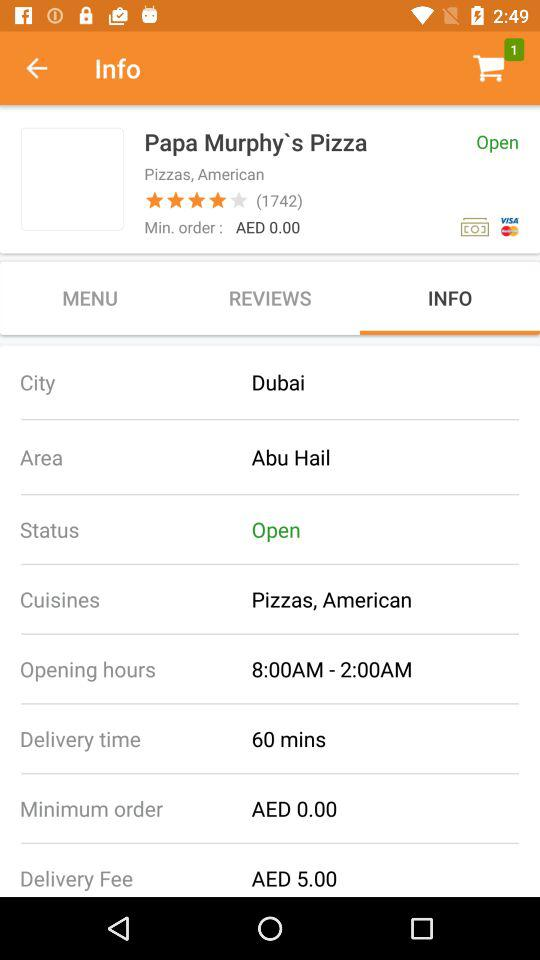What are the opening hours? The opening hours are from 8 a.m. to 2 a.m. 